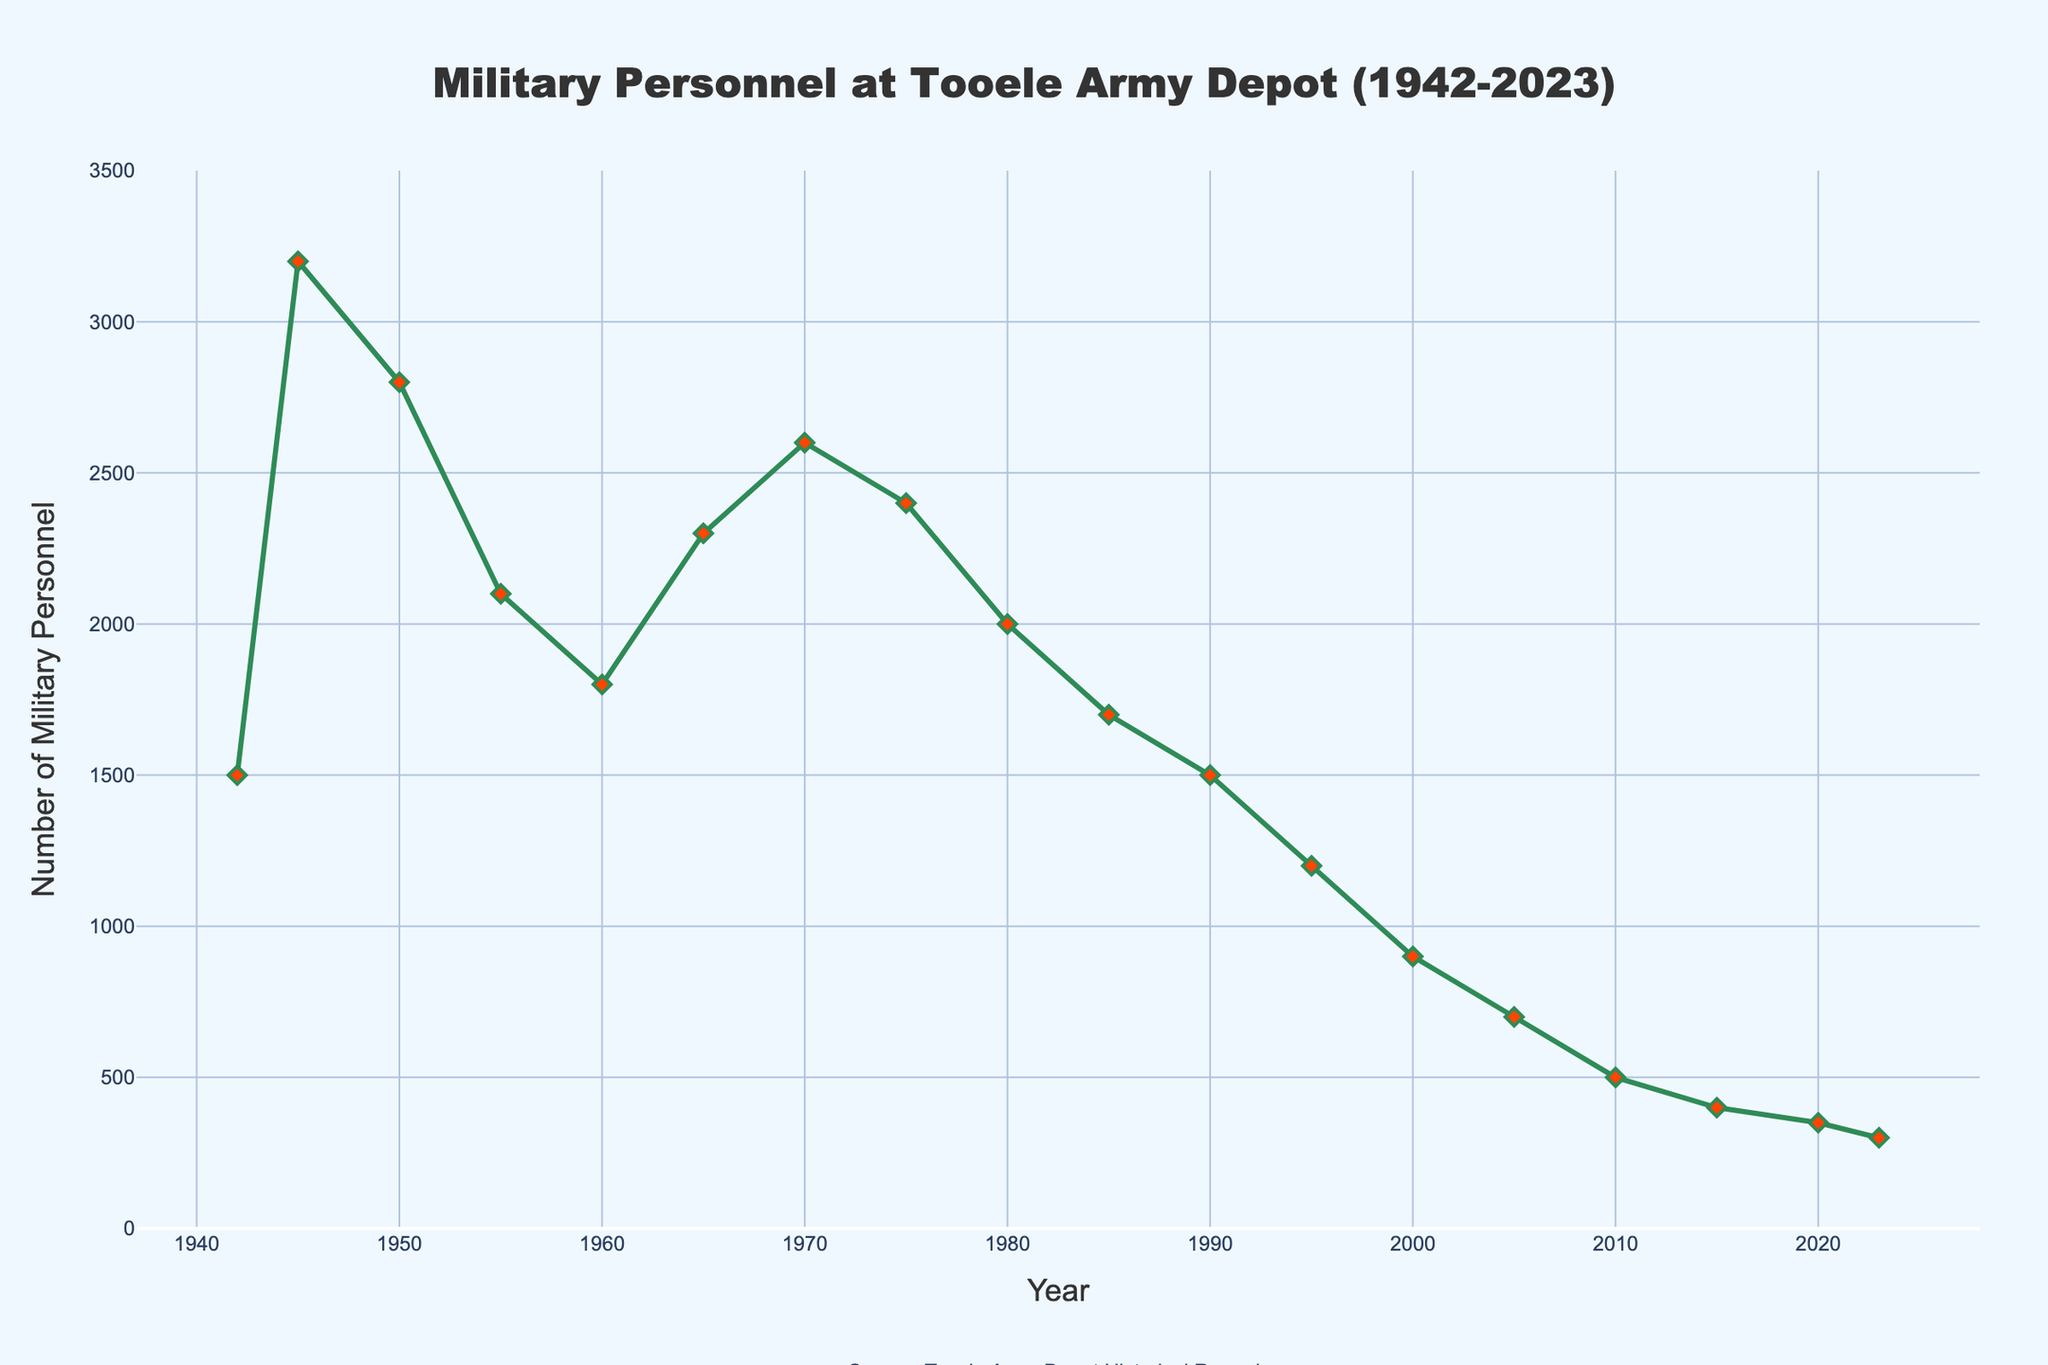What was the highest number of military personnel stationed at Tooele Army Depot? By examining the line chart, the highest military personnel count can be found at the peak point. The peak occurs in 1945 with a personnel count of 3200.
Answer: 3200 How did the number of military personnel change from 1942 to 1945? To determine the change, subtract the military personnel count in 1942 from the count in 1945: 3200 - 1500 = 1700.
Answer: Increased by 1700 Between which two consecutive years did the number of military personnel decrease the most? Evaluate the decreases between each consecutive pair of years by calculating the differences. The largest drop is between 1990 and 1995 (1500 - 1200 = 300).
Answer: 1990 and 1995 What is the average number of military personnel at Tooele Army Depot for the years 1942, 1945, 1950, and 1955? Calculate the average by summing the personnel counts and dividing by the number of years: (1500 + 3200 + 2800 + 2100) / 4 = 2400.
Answer: 2400 Which year saw the military personnel count drop below 1000 for the first time? Identify the first year where the personnel count is less than 1000 by scanning the chart. This occurs in the year 2000 with 900 personnel.
Answer: 2000 What trend can be observed in the military personnel count from 2010 to 2023? Observing the line chart from 2010 to 2023, it shows a downward trend in the number of military personnel.
Answer: Downward trend What was the difference in the number of military personnel between 1960 and 1970? Calculate the difference between the two years: 2600 - 1800 = 800.
Answer: 800 How does the number of military personnel in 2023 compare to 1970? Compare the counts from 2023 (300) and 1970 (2600). The 2023 count is significantly lower than the 1970 count.
Answer: Lower When did the number of military personnel start to consistently fall below 1000? By examining the plot, the number consistently remains below 1000 starting from 2000 and continues in the subsequent years.
Answer: 2000 What color represents the line denoting the number of military personnel? The line tracing the number of military personnel is in green.
Answer: Green 